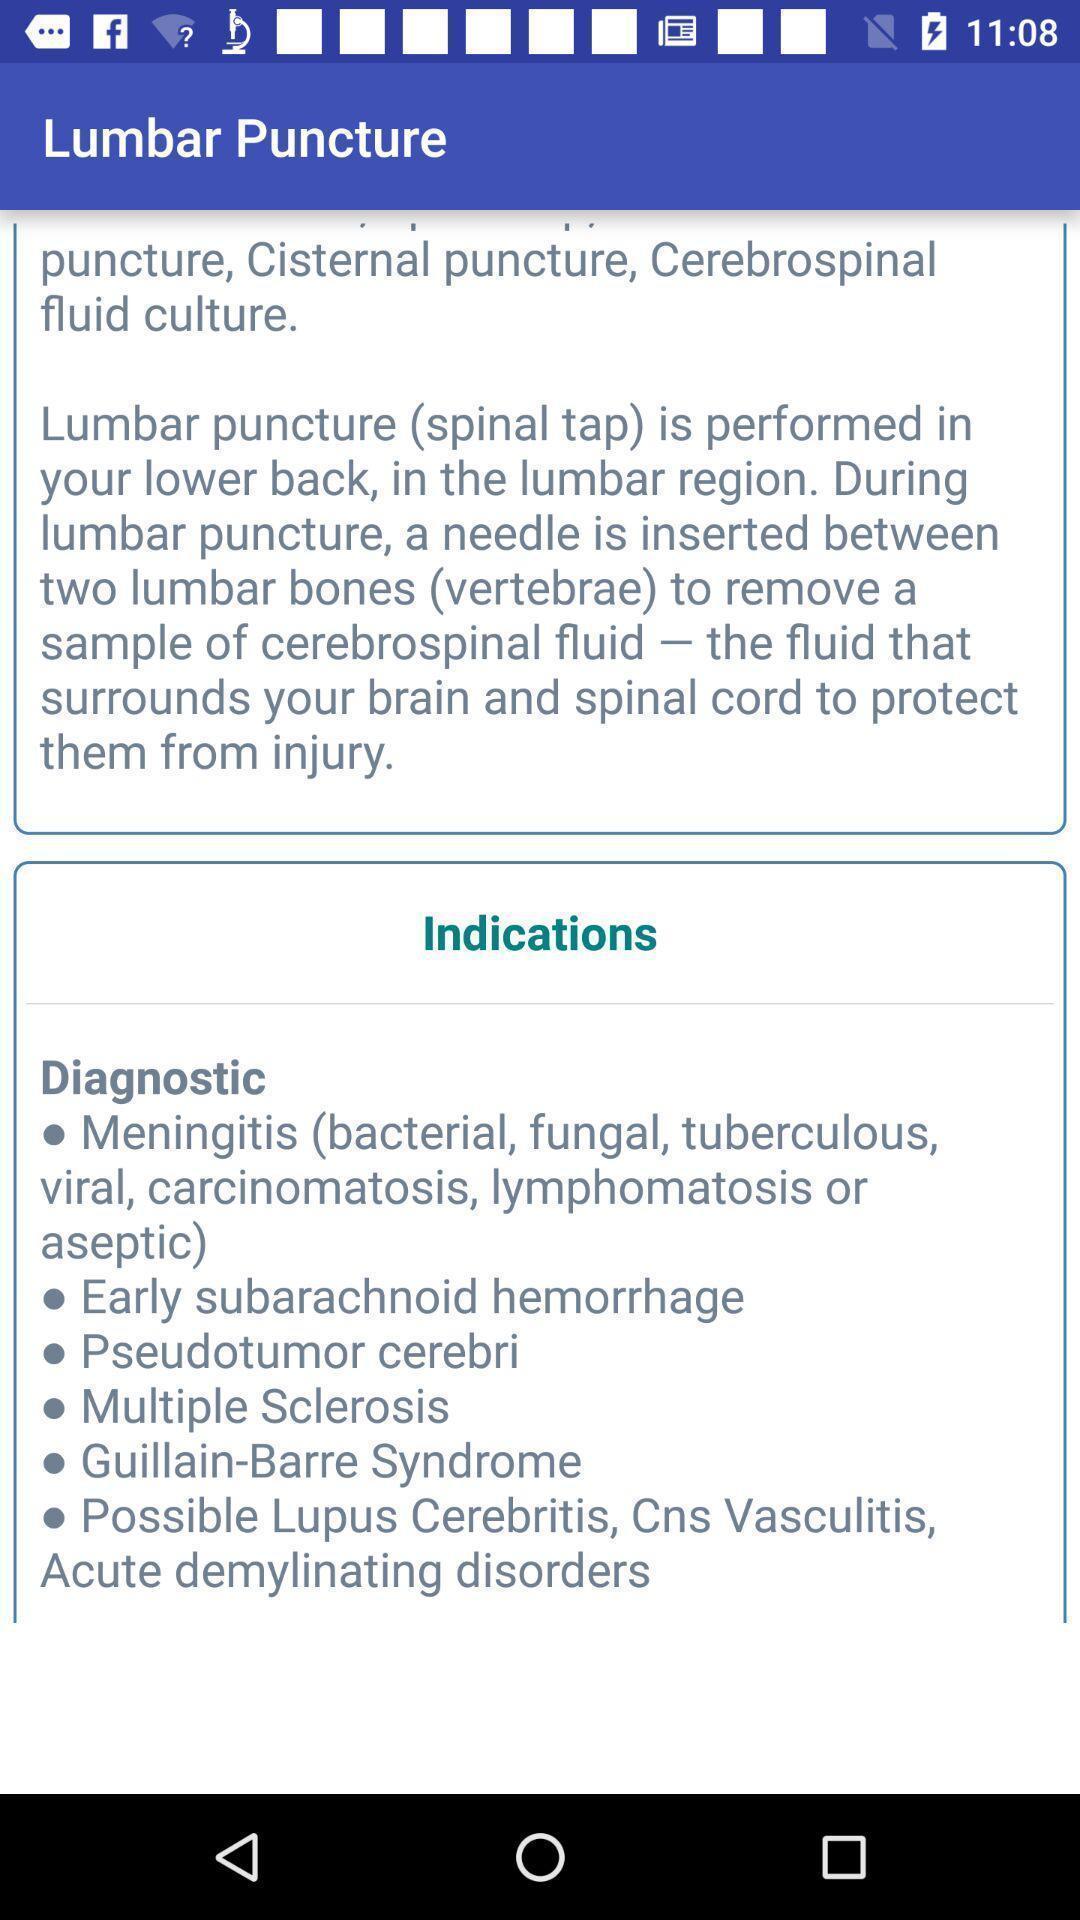Tell me what you see in this picture. Page displaying the lumbar puncture options. 